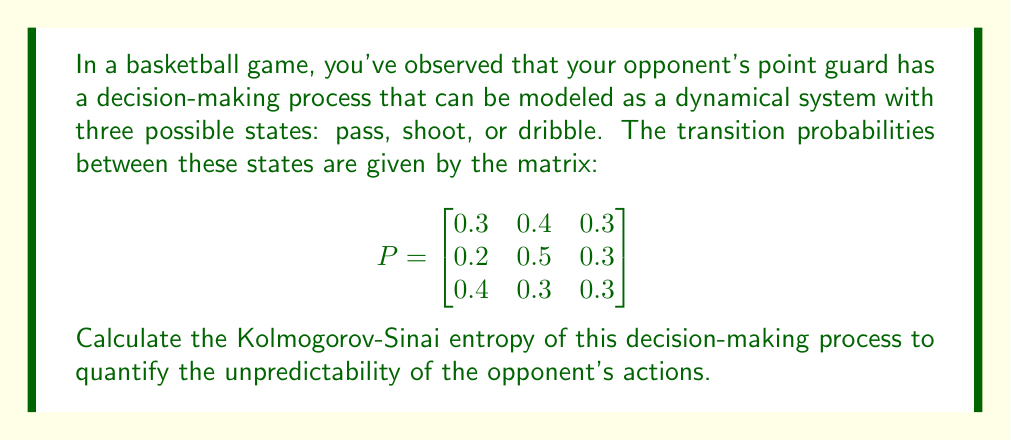Could you help me with this problem? To compute the Kolmogorov-Sinai entropy of the opponent's decision-making process, we'll follow these steps:

1) First, we need to find the stationary distribution $\pi$ of the Markov chain. This is the left eigenvector of P with eigenvalue 1, normalized so its components sum to 1. We can solve the equation:

   $$\pi P = \pi$$

   Using numerical methods or a computer algebra system, we find:
   
   $$\pi \approx [0.3077, 0.3846, 0.3077]$$

2) Next, we calculate the entropy rate using the formula:

   $$h = -\sum_{i,j} \pi_i P_{ij} \log P_{ij}$$

   Where $\pi_i$ is the i-th component of $\pi$, and $P_{ij}$ is the element in the i-th row and j-th column of P.

3) Let's calculate each term:

   For i = 1:
   $0.3077 * (0.3 * \log(0.3) + 0.4 * \log(0.4) + 0.3 * \log(0.3))$

   For i = 2:
   $0.3846 * (0.2 * \log(0.2) + 0.5 * \log(0.5) + 0.3 * \log(0.3))$

   For i = 3:
   $0.3077 * (0.4 * \log(0.4) + 0.3 * \log(0.3) + 0.3 * \log(0.3))$

4) Sum all these terms and multiply by -1:

   $$h \approx 1.0614$$

5) This value represents the Kolmogorov-Sinai entropy of the opponent's decision-making process, measured in bits per decision (assuming we used base-2 logarithms).
Answer: $1.0614$ bits per decision 